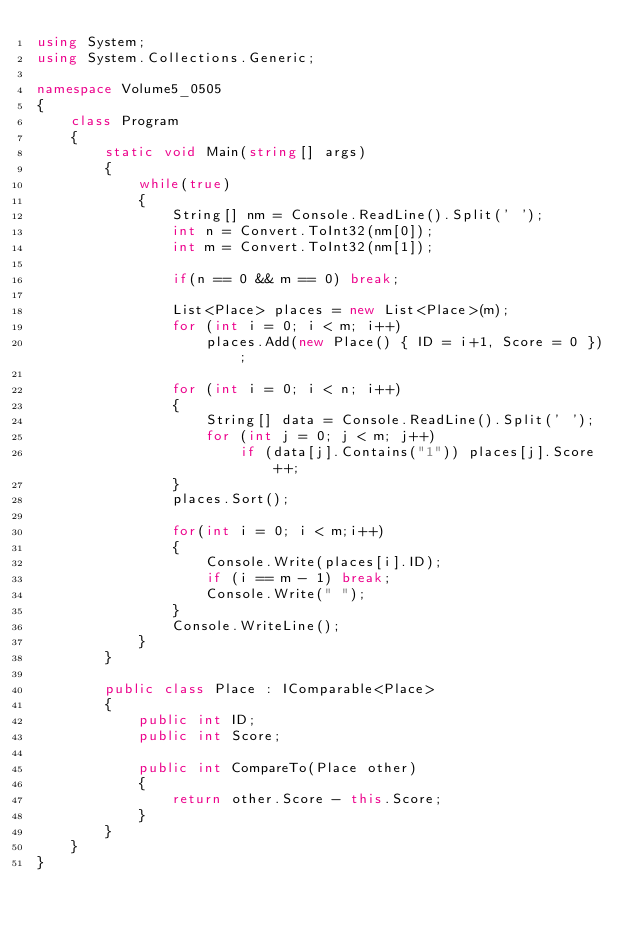Convert code to text. <code><loc_0><loc_0><loc_500><loc_500><_C#_>using System;
using System.Collections.Generic;

namespace Volume5_0505
{
    class Program
    {
        static void Main(string[] args)
        {
            while(true)
            {
                String[] nm = Console.ReadLine().Split(' ');
                int n = Convert.ToInt32(nm[0]);
                int m = Convert.ToInt32(nm[1]);

                if(n == 0 && m == 0) break;

                List<Place> places = new List<Place>(m);
                for (int i = 0; i < m; i++)
                    places.Add(new Place() { ID = i+1, Score = 0 });

                for (int i = 0; i < n; i++)
                {
                    String[] data = Console.ReadLine().Split(' ');
                    for (int j = 0; j < m; j++)
                        if (data[j].Contains("1")) places[j].Score++;
                }
                places.Sort();

                for(int i = 0; i < m;i++)
                {
                    Console.Write(places[i].ID);
                    if (i == m - 1) break;
                    Console.Write(" ");
                }
                Console.WriteLine();
            }
        }

        public class Place : IComparable<Place>
        {
            public int ID;
            public int Score;

            public int CompareTo(Place other)
            {
                return other.Score - this.Score;
            }
        }
    }
}</code> 